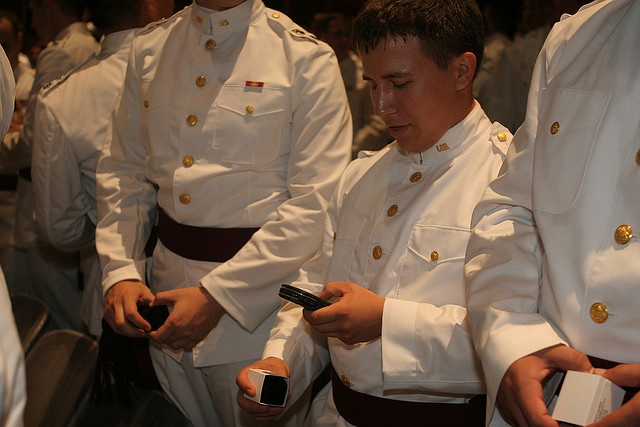Describe the objects in this image and their specific colors. I can see people in black, gray, and tan tones, people in black, maroon, and gray tones, people in black, gray, and darkgray tones, people in black, maroon, and tan tones, and people in black, tan, gray, and maroon tones in this image. 